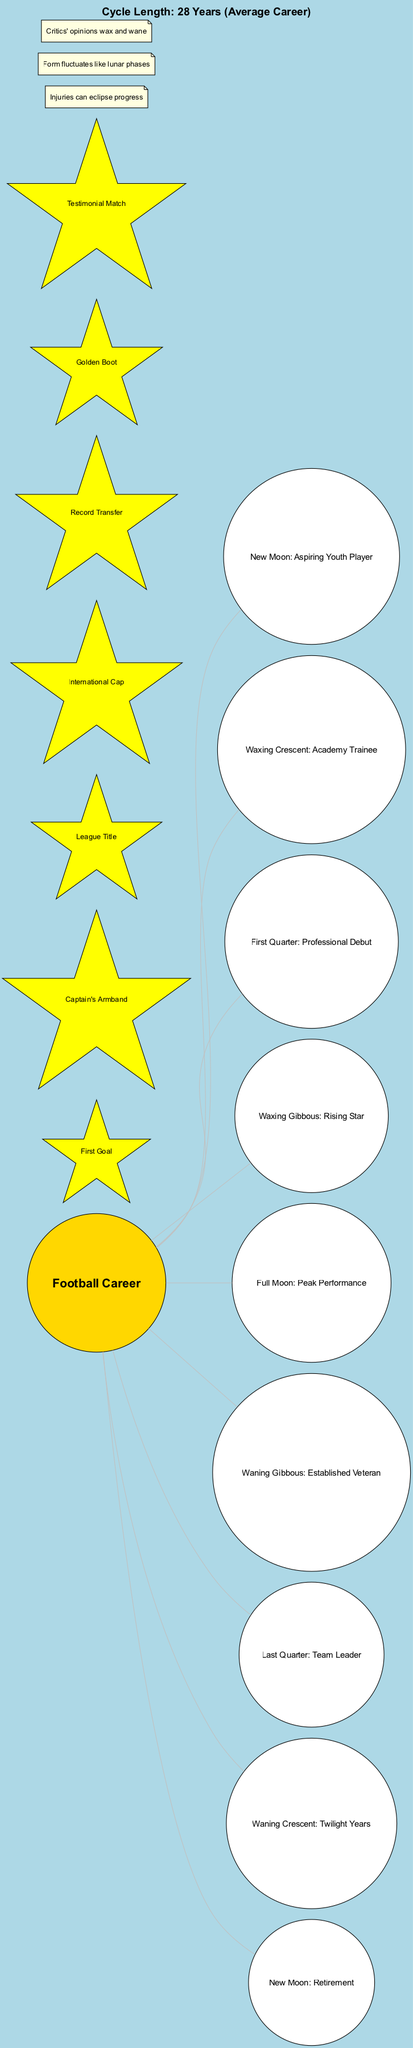What is the main theme represented in the diagram? The center of the diagram highlights "Football Career," which is the primary focus connecting various elements, illustrating the relationship between moon phases and stages of a football career.
Answer: Football Career How many moon phases are illustrated? The diagram shows eight distinct moon phases, each representing a stage in a football career, traced around the central theme.
Answer: 8 What phase corresponds to a player's peak performance? The "Full Moon" phase is matched to the "Peak Performance," indicating the height of a player's career accomplishments.
Answer: Full Moon: Peak Performance What milestone is represented by the "Last Quarter"? The "Last Quarter" corresponds to "Team Leader," showing the player's transition to a leadership role as they approach the end of their career.
Answer: Team Leader What noteworthy point mentions the unpredictability of form? The noteworthy point stating "Form fluctuates like lunar phases" captures the inconsistency players can experience in their performance throughout their careers.
Answer: Form fluctuates like lunar phases Which phase signifies the beginning of a football career? "New Moon" represents the starting point of a football career, metaphorically likening it to an aspiring youth player.
Answer: New Moon: Aspiring Youth Player How many career milestones are included in the diagram? The diagram contains seven distinct career milestones that represent accomplishments throughout a football player's journey.
Answer: 7 What does the "Waning Gibbous" phase signify? The "Waning Gibbous" phase is connected to "Established Veteran," illustrating the stage where a player has substantial experience but is past their peak.
Answer: Established Veteran What is the cycle length representing the average football career? The diagram indicates that the average career length is depicted as "28 Years," which is the full cycle noted in the diagram.
Answer: 28 Years 